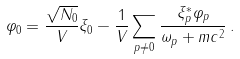Convert formula to latex. <formula><loc_0><loc_0><loc_500><loc_500>\varphi _ { 0 } = \frac { \sqrt { N _ { 0 } } } { V } \xi _ { 0 } - \frac { 1 } { V } \sum _ { p \ne 0 } \frac { \xi _ { p } ^ { * } \varphi _ { p } } { \omega _ { p } + m c ^ { 2 } } \, .</formula> 